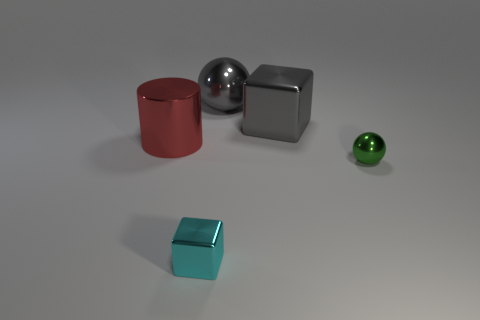Does the cube behind the green shiny object have the same color as the big ball?
Make the answer very short. Yes. There is a large metallic ball; is it the same color as the metallic block behind the big red cylinder?
Your answer should be compact. Yes. What is the color of the small sphere that is the same material as the tiny block?
Offer a very short reply. Green. What number of gray balls have the same size as the metal cylinder?
Ensure brevity in your answer.  1. How many gray things are either big spheres or large shiny cubes?
Provide a short and direct response. 2. What number of objects are big blue matte things or metal things to the right of the large cylinder?
Provide a succinct answer. 4. There is a gray shiny thing that is the same size as the gray ball; what is its shape?
Your answer should be compact. Cube. Are there any other large metal things of the same shape as the green object?
Your answer should be very brief. Yes. Is the number of big gray objects that are to the right of the small metal cube greater than the number of gray matte objects?
Your response must be concise. Yes. Are any large red matte balls visible?
Ensure brevity in your answer.  No. 